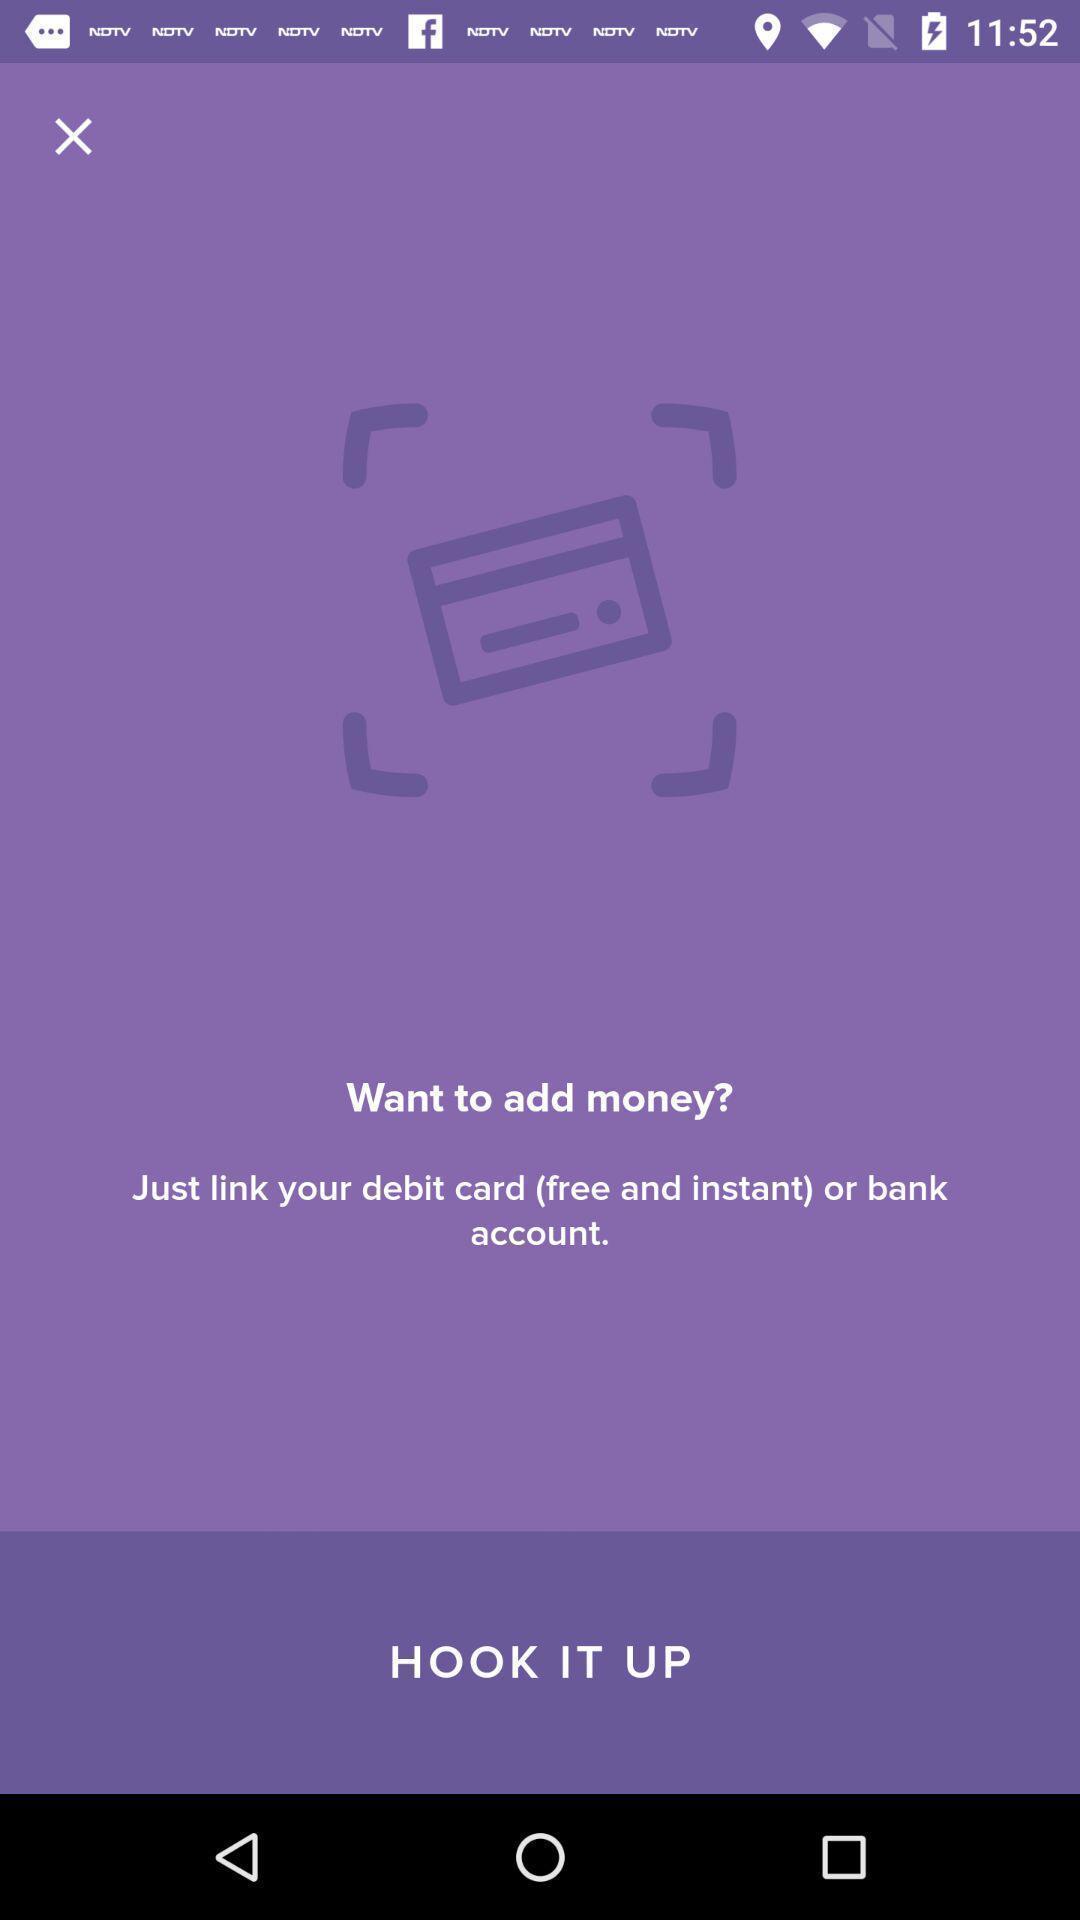Describe the content in this image. Welcome page for the payment app. 